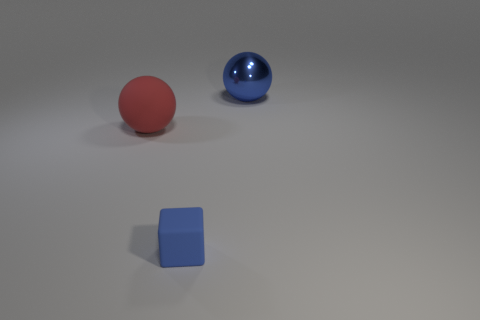Do the cube and the large object behind the large red matte sphere have the same color?
Make the answer very short. Yes. How many matte balls have the same color as the tiny rubber cube?
Your answer should be compact. 0. What number of things are either green things or large objects that are on the right side of the big red sphere?
Your response must be concise. 1. The small thing is what color?
Provide a succinct answer. Blue. What color is the ball on the left side of the tiny blue rubber thing?
Keep it short and to the point. Red. There is a big blue ball behind the block; how many matte balls are behind it?
Make the answer very short. 0. Do the red matte thing and the blue thing that is behind the blue cube have the same size?
Provide a succinct answer. Yes. Are there any things of the same size as the matte sphere?
Offer a very short reply. Yes. What number of objects are small green objects or tiny matte things?
Give a very brief answer. 1. Do the object that is behind the big red matte object and the matte object on the left side of the small block have the same size?
Make the answer very short. Yes. 